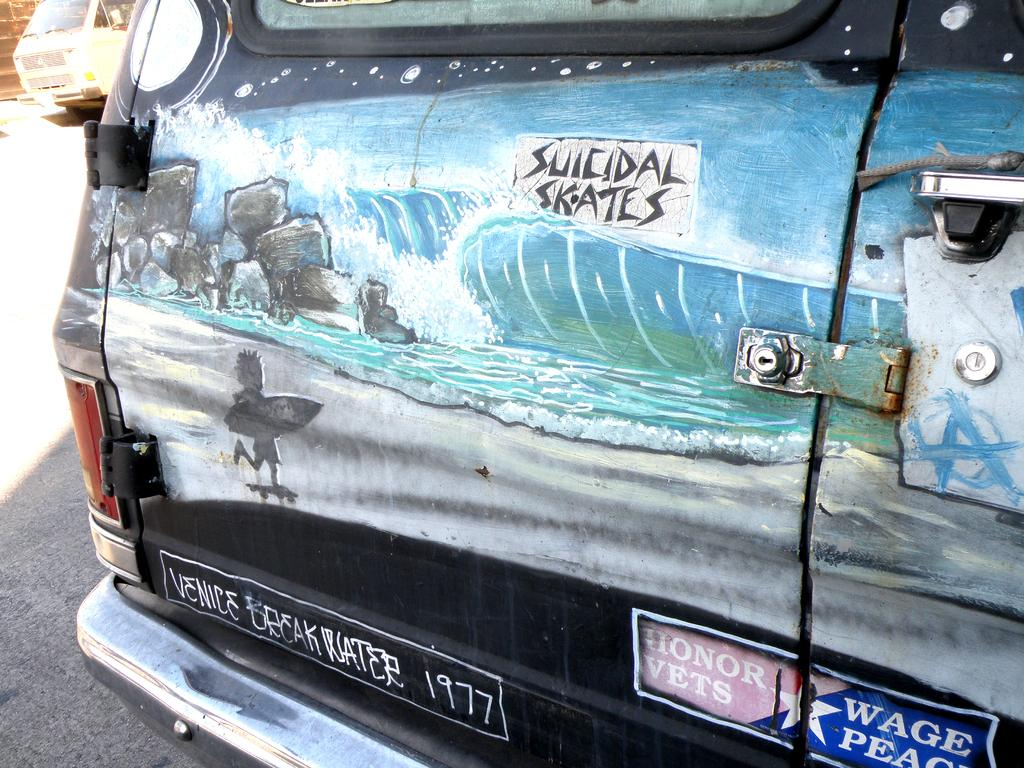What is the main subject of the image? There is a vehicle parked in the image. Can you describe another vehicle in the image? Yes, there is a vehicle visible in the background of the image. What can be seen in the background of the image besides the vehicle? There is a wall in the background of the image. How does the hour affect the rainstorm in the image? There is no rainstorm present in the image, so the hour cannot affect it. 